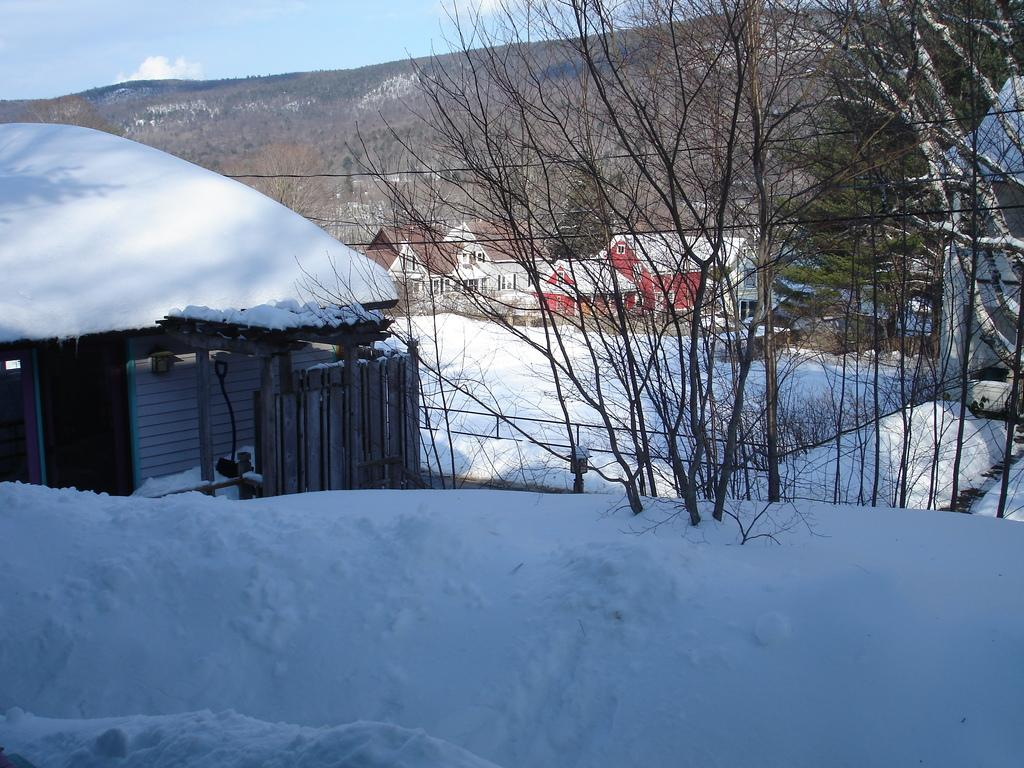What type of natural environment is depicted at the bottom of the image? There is snow at the bottom of the image. What type of geographical features can be seen in the background of the image? There are mountains in the background of the image. What type of man-made structures are visible in the background of the image? There are buildings in the background of the image. What type of vegetation is present in the background of the image? There are trees in the background of the image. What type of relation does the army have with the parent in the image? There is no army or parent present in the image. 